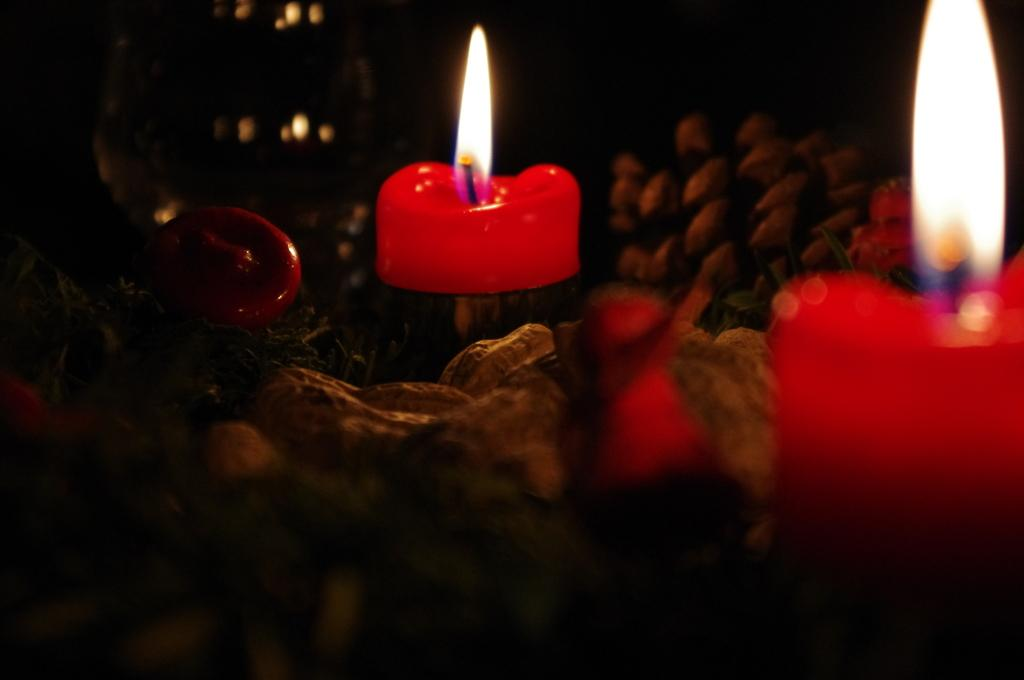What is burning in the image? There are candles with flames in the image. What type of food waste can be seen in the image? There are groundnut shells in the image. Can you describe any other objects present in the image? Yes, there are other objects in the image, but their specific details are not mentioned in the provided facts. How would you describe the lighting in the image? The overall view of the image is dark. Can you touch the ice in the image? There is no ice present in the image, so it cannot be touched. Is there a kitty visible in the image? There is no mention of a kitty in the provided facts, so it cannot be confirmed or denied. 